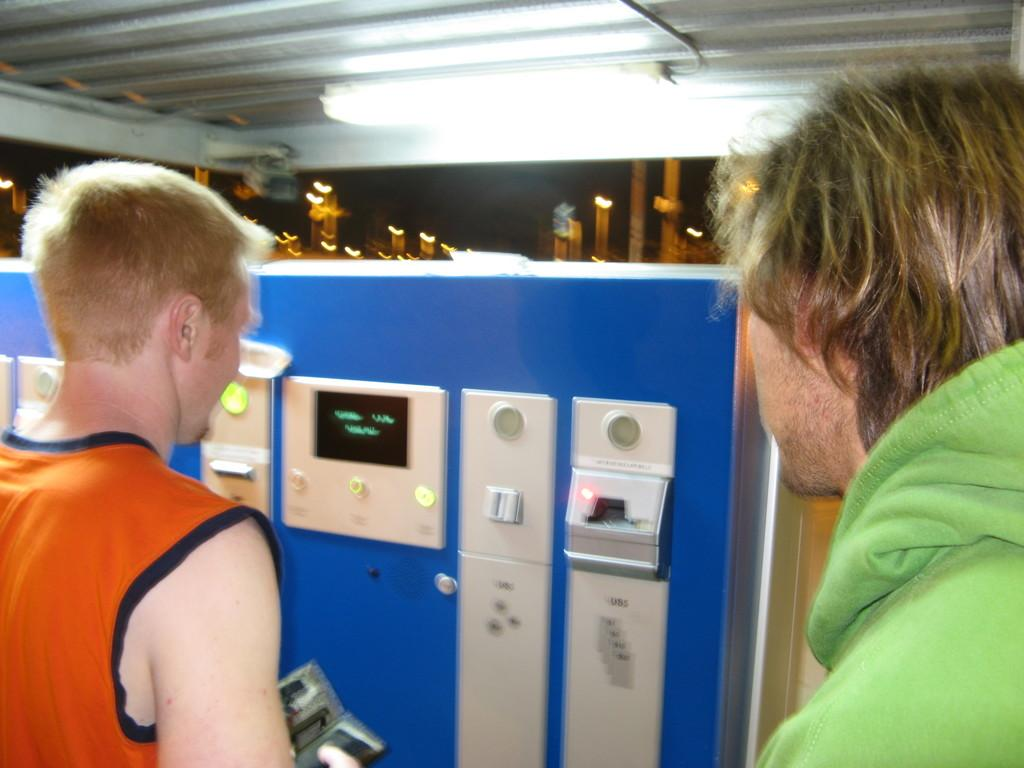How many people are present in the image? There are two people in the image. What is one person doing in the image? One person is holding an item. What type of device can be seen in the image? There is an electronic machine with a screen in the image. What can be observed in terms of lighting in the image? There are lights visible in the image. What type of behavior is the banana exhibiting in the image? There is no banana present in the image, so it cannot exhibit any behavior. 